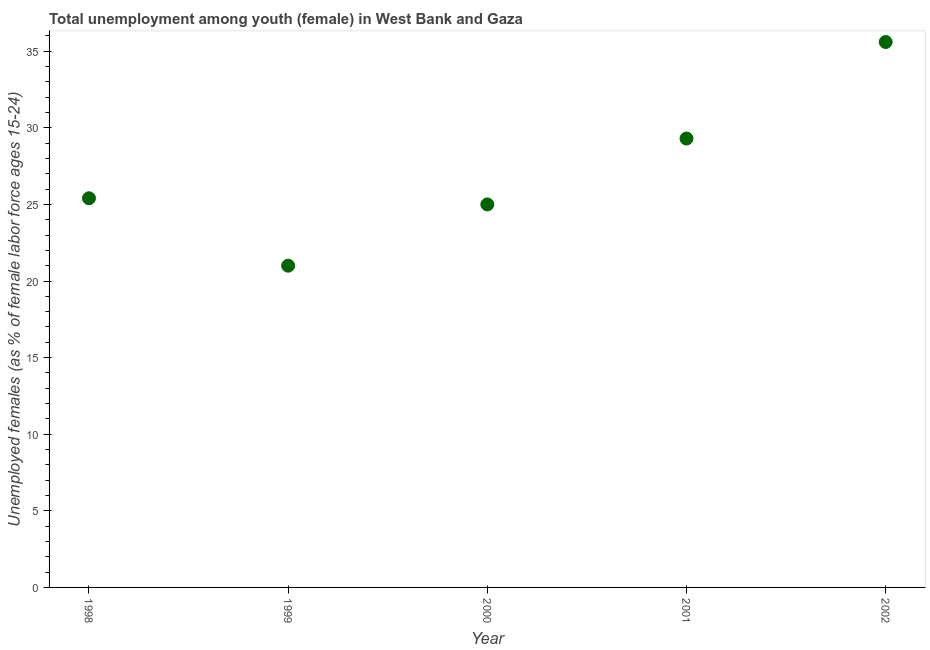What is the unemployed female youth population in 2001?
Provide a succinct answer. 29.3. Across all years, what is the maximum unemployed female youth population?
Your answer should be compact. 35.6. Across all years, what is the minimum unemployed female youth population?
Your answer should be very brief. 21. In which year was the unemployed female youth population maximum?
Make the answer very short. 2002. In which year was the unemployed female youth population minimum?
Ensure brevity in your answer.  1999. What is the sum of the unemployed female youth population?
Provide a short and direct response. 136.3. What is the difference between the unemployed female youth population in 1998 and 2001?
Give a very brief answer. -3.9. What is the average unemployed female youth population per year?
Offer a very short reply. 27.26. What is the median unemployed female youth population?
Ensure brevity in your answer.  25.4. In how many years, is the unemployed female youth population greater than 24 %?
Your answer should be very brief. 4. What is the ratio of the unemployed female youth population in 1998 to that in 2002?
Make the answer very short. 0.71. Is the unemployed female youth population in 1999 less than that in 2000?
Provide a succinct answer. Yes. What is the difference between the highest and the second highest unemployed female youth population?
Give a very brief answer. 6.3. Is the sum of the unemployed female youth population in 1998 and 2001 greater than the maximum unemployed female youth population across all years?
Offer a terse response. Yes. What is the difference between the highest and the lowest unemployed female youth population?
Offer a very short reply. 14.6. Does the unemployed female youth population monotonically increase over the years?
Ensure brevity in your answer.  No. What is the difference between two consecutive major ticks on the Y-axis?
Your response must be concise. 5. Does the graph contain grids?
Offer a very short reply. No. What is the title of the graph?
Offer a very short reply. Total unemployment among youth (female) in West Bank and Gaza. What is the label or title of the Y-axis?
Your answer should be compact. Unemployed females (as % of female labor force ages 15-24). What is the Unemployed females (as % of female labor force ages 15-24) in 1998?
Provide a succinct answer. 25.4. What is the Unemployed females (as % of female labor force ages 15-24) in 2000?
Offer a terse response. 25. What is the Unemployed females (as % of female labor force ages 15-24) in 2001?
Offer a terse response. 29.3. What is the Unemployed females (as % of female labor force ages 15-24) in 2002?
Offer a very short reply. 35.6. What is the difference between the Unemployed females (as % of female labor force ages 15-24) in 1998 and 1999?
Ensure brevity in your answer.  4.4. What is the difference between the Unemployed females (as % of female labor force ages 15-24) in 1998 and 2000?
Your answer should be compact. 0.4. What is the difference between the Unemployed females (as % of female labor force ages 15-24) in 1998 and 2001?
Offer a very short reply. -3.9. What is the difference between the Unemployed females (as % of female labor force ages 15-24) in 1998 and 2002?
Offer a very short reply. -10.2. What is the difference between the Unemployed females (as % of female labor force ages 15-24) in 1999 and 2001?
Give a very brief answer. -8.3. What is the difference between the Unemployed females (as % of female labor force ages 15-24) in 1999 and 2002?
Provide a succinct answer. -14.6. What is the difference between the Unemployed females (as % of female labor force ages 15-24) in 2000 and 2001?
Keep it short and to the point. -4.3. What is the difference between the Unemployed females (as % of female labor force ages 15-24) in 2001 and 2002?
Ensure brevity in your answer.  -6.3. What is the ratio of the Unemployed females (as % of female labor force ages 15-24) in 1998 to that in 1999?
Offer a terse response. 1.21. What is the ratio of the Unemployed females (as % of female labor force ages 15-24) in 1998 to that in 2001?
Ensure brevity in your answer.  0.87. What is the ratio of the Unemployed females (as % of female labor force ages 15-24) in 1998 to that in 2002?
Your response must be concise. 0.71. What is the ratio of the Unemployed females (as % of female labor force ages 15-24) in 1999 to that in 2000?
Your answer should be very brief. 0.84. What is the ratio of the Unemployed females (as % of female labor force ages 15-24) in 1999 to that in 2001?
Your answer should be very brief. 0.72. What is the ratio of the Unemployed females (as % of female labor force ages 15-24) in 1999 to that in 2002?
Offer a very short reply. 0.59. What is the ratio of the Unemployed females (as % of female labor force ages 15-24) in 2000 to that in 2001?
Provide a short and direct response. 0.85. What is the ratio of the Unemployed females (as % of female labor force ages 15-24) in 2000 to that in 2002?
Your answer should be compact. 0.7. What is the ratio of the Unemployed females (as % of female labor force ages 15-24) in 2001 to that in 2002?
Ensure brevity in your answer.  0.82. 